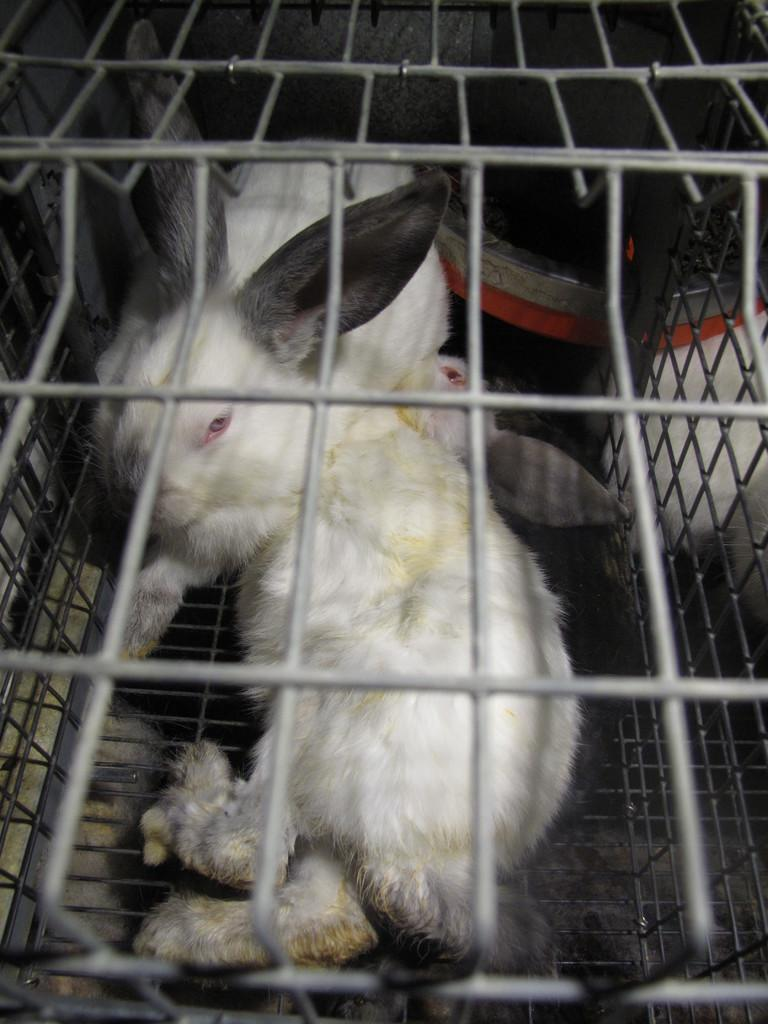What type of animals are present in the image? There are rabbits in the image. Where are the rabbits located? The rabbits are in a welded mesh wire box. Can you describe the object in the image? Unfortunately, the facts provided do not give enough information to describe the object in the image. What is the rabbits' memory like in the image? There is no information provided about the rabbits' memory in the image. Rabbits do not have the ability to remember like humans, so it is not possible to determine their memory from the image. 